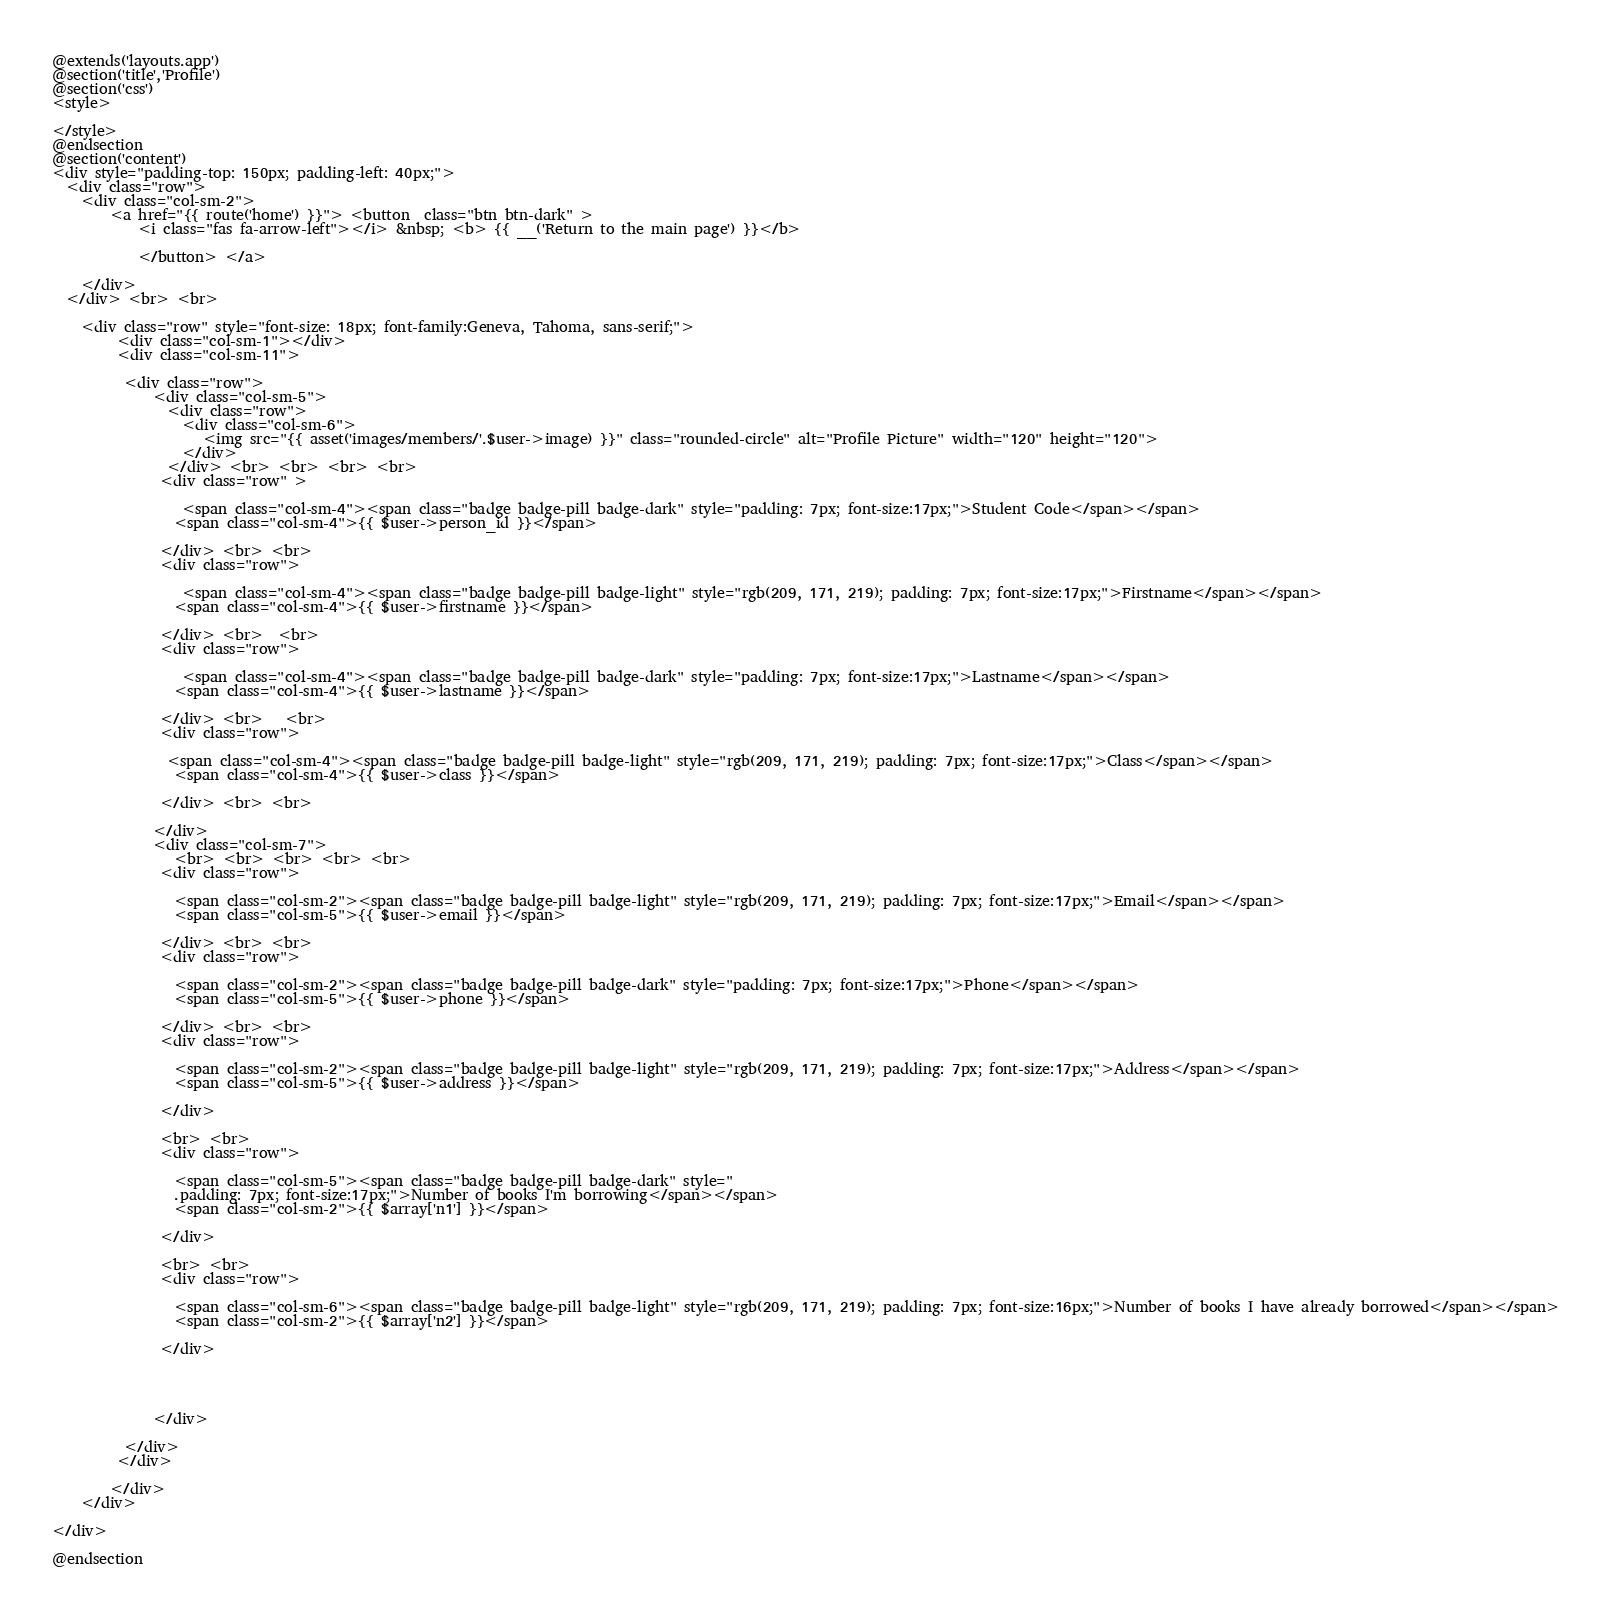Convert code to text. <code><loc_0><loc_0><loc_500><loc_500><_PHP_>@extends('layouts.app')
@section('title','Profile')
@section('css')
<style>

</style>
@endsection
@section('content')    
<div style="padding-top: 150px; padding-left: 40px;">
  <div class="row">
    <div class="col-sm-2">
        <a href="{{ route('home') }}"> <button  class="btn btn-dark" >
            <i class="fas fa-arrow-left"></i> &nbsp; <b> {{ __('Return to the main page') }}</b> 
                
            </button> </a> 
            
    </div>
  </div> <br> <br> 
  
    <div class="row" style="font-size: 18px; font-family:Geneva, Tahoma, sans-serif;">
         <div class="col-sm-1"></div>
         <div class="col-sm-11">
          
          <div class="row">
              <div class="col-sm-5">
                <div class="row">
                  <div class="col-sm-6">
                     <img src="{{ asset('images/members/'.$user->image) }}" class="rounded-circle" alt="Profile Picture" width="120" height="120">
                  </div>
                </div> <br> <br> <br> <br> 
               <div class="row" >
                 
                  <span class="col-sm-4"><span class="badge badge-pill badge-dark" style="padding: 7px; font-size:17px;">Student Code</span></span> 
                 <span class="col-sm-4">{{ $user->person_id }}</span>
                
               </div> <br> <br>
               <div class="row">
                 
                  <span class="col-sm-4"><span class="badge badge-pill badge-light" style="rgb(209, 171, 219); padding: 7px; font-size:17px;">Firstname</span></span> 
                 <span class="col-sm-4">{{ $user->firstname }}</span>
           
               </div> <br>  <br> 
               <div class="row">
                 
                  <span class="col-sm-4"><span class="badge badge-pill badge-dark" style="padding: 7px; font-size:17px;">Lastname</span></span> 
                 <span class="col-sm-4">{{ $user->lastname }}</span>
             
               </div> <br>   <br>
               <div class="row">
               
                <span class="col-sm-4"><span class="badge badge-pill badge-light" style="rgb(209, 171, 219); padding: 7px; font-size:17px;">Class</span></span> 
                 <span class="col-sm-4">{{ $user->class }}</span>
           
               </div> <br> <br> 
               
              </div>
              <div class="col-sm-7">
                 <br> <br> <br> <br> <br> 
               <div class="row">
                 
                 <span class="col-sm-2"><span class="badge badge-pill badge-light" style="rgb(209, 171, 219); padding: 7px; font-size:17px;">Email</span></span> 
                 <span class="col-sm-5">{{ $user->email }}</span>
               
               </div> <br> <br>
               <div class="row">
                 
                 <span class="col-sm-2"><span class="badge badge-pill badge-dark" style="padding: 7px; font-size:17px;">Phone</span></span> 
                 <span class="col-sm-5">{{ $user->phone }}</span>
              
               </div> <br> <br>
               <div class="row">
                
                 <span class="col-sm-2"><span class="badge badge-pill badge-light" style="rgb(209, 171, 219); padding: 7px; font-size:17px;">Address</span></span> 
                 <span class="col-sm-5">{{ $user->address }}</span>
               
               </div>

               <br> <br>
               <div class="row">
                
                 <span class="col-sm-5"><span class="badge badge-pill badge-dark" style="
                 .padding: 7px; font-size:17px;">Number of books I'm borrowing</span></span> 
                 <span class="col-sm-2">{{ $array['n1'] }}</span>
                
               </div>

               <br> <br>
               <div class="row">
                 
                 <span class="col-sm-6"><span class="badge badge-pill badge-light" style="rgb(209, 171, 219); padding: 7px; font-size:16px;">Number of books I have already borrowed</span></span> 
                 <span class="col-sm-2">{{ $array['n2'] }}</span>
               
               </div>




              </div>
           
          </div>
         </div>
         
        </div>  
    </div>
  
</div> 

@endsection</code> 